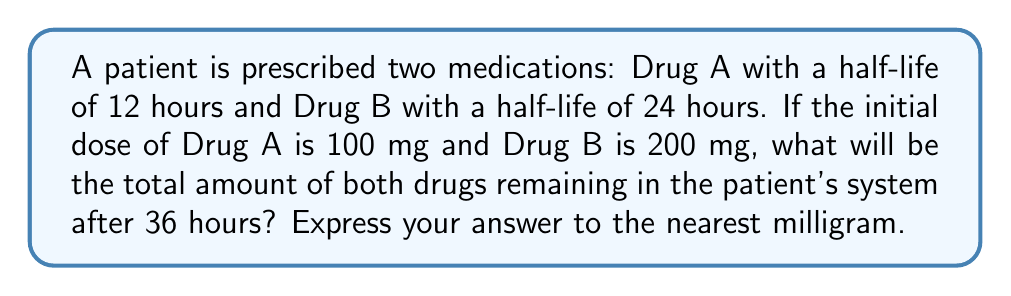Could you help me with this problem? To solve this problem, we need to calculate the amount of each drug remaining after 36 hours and then sum them up. We'll use the exponential decay formula:

$A(t) = A_0 \cdot (\frac{1}{2})^{\frac{t}{t_{1/2}}}$

Where:
$A(t)$ is the amount remaining after time $t$
$A_0$ is the initial amount
$t$ is the time elapsed
$t_{1/2}$ is the half-life of the drug

For Drug A:
$A_0 = 100$ mg
$t = 36$ hours
$t_{1/2} = 12$ hours

$A_A(36) = 100 \cdot (\frac{1}{2})^{\frac{36}{12}} = 100 \cdot (\frac{1}{2})^3 = 100 \cdot \frac{1}{8} = 12.5$ mg

For Drug B:
$A_0 = 200$ mg
$t = 36$ hours
$t_{1/2} = 24$ hours

$A_B(36) = 200 \cdot (\frac{1}{2})^{\frac{36}{24}} = 200 \cdot (\frac{1}{2})^{1.5} = 200 \cdot \frac{1}{\sqrt{8}} \approx 70.71$ mg

Total amount remaining:
$A_{total} = A_A(36) + A_B(36) = 12.5 + 70.71 = 83.21$ mg

Rounding to the nearest milligram: 83 mg
Answer: 83 mg 